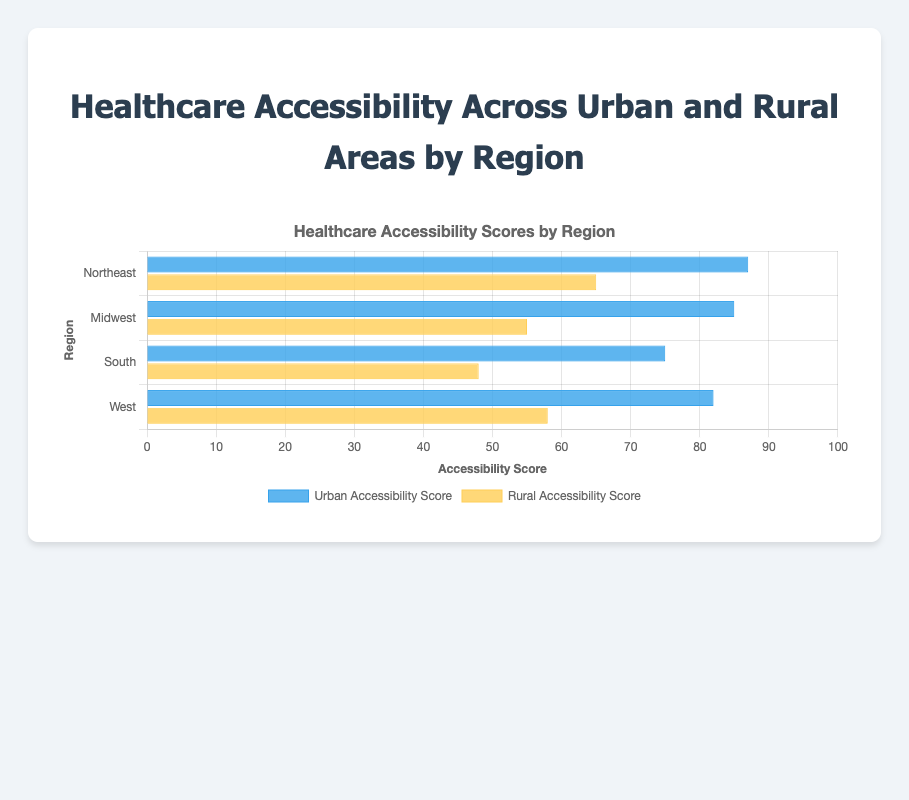What are the urban and rural accessibility scores for the Midwest region? The chart shows that the Midwest region has distinct bars representing urban and rural scores. The urban accessibility score is 85, while the rural accessibility score is 55.
Answer: Urban: 85, Rural: 55 Which region has the highest rural accessibility score, and what is that score? By looking at the longest yellow bar representing rural accessibility scores, the Northeast region has the highest score of 65.
Answer: Northeast, 65 How much higher is the urban accessibility score in the Northeast compared to the South? The urban scores for the Northeast and South are presented by blue bars. The Northeast's score is 87, and the South's is 75. The difference is 87 - 75 = 12.
Answer: 12 Compare the urban and rural accessibility scores in the West region. Which is higher? In the West region, the blue (urban) bar is longer than the yellow (rural) bar. Urban accessibility is 82, while rural accessibility is 58. Thus, urban accessibility is higher.
Answer: Urban is higher What is the average rural accessibility score across all regions? To calculate the average, sum the rural scores (65 + 55 + 48 + 58) and divide by the number of regions (4). The sum is 226, so the average is 226 / 4 = 56.5.
Answer: 56.5 Which region has the largest disparity between urban and rural accessibility scores and what is that disparity? For each region, find the difference between urban and rural scores: Northeast (22), Midwest (30), South (27), West (24). The Midwest has the largest disparity of 30.
Answer: Midwest, 30 In which regions is the urban accessibility score at least 80? Regions with urban scores 80 or above are represented by the blue bars reaching the 80 mark. These regions are Northeast (87), Midwest (85), and West (82).
Answer: Northeast, Midwest, West What is the combined urban and rural accessibility score for the South region? Sum the urban and rural scores of the South region: 75 (urban) + 48 (rural) = 123.
Answer: 123 Which color represents higher values on average, blue or yellow? Average the values represented by blue (urban) and yellow (rural). Urban: (87 + 85 + 75 + 82) / 4 = 82.25. Rural: (65 + 55 + 48 + 58) / 4 = 56.5. Blue represents higher values.
Answer: Blue Is there any region where the rural accessibility score is at least 60? Examine the lengths of yellow bars representing rural scores. None of the bars reach the 60 mark; the highest is 65 for Northeast, but it surpasses 60. This score hasn't occurred in the West, Midwest, or South.
Answer: No 